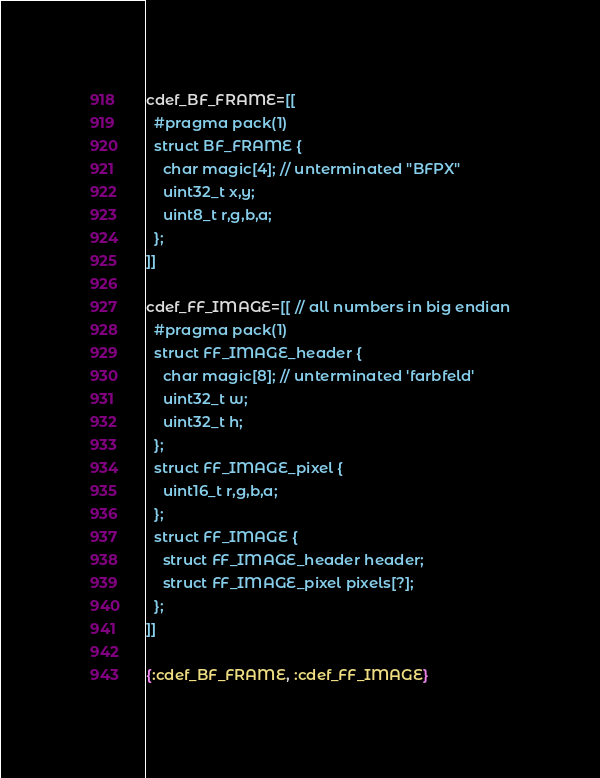<code> <loc_0><loc_0><loc_500><loc_500><_MoonScript_>cdef_BF_FRAME=[[
  #pragma pack(1)
  struct BF_FRAME {
    char magic[4]; // unterminated "BFPX"
    uint32_t x,y;
    uint8_t r,g,b,a;
  };
]]

cdef_FF_IMAGE=[[ // all numbers in big endian
  #pragma pack(1)
  struct FF_IMAGE_header {
    char magic[8]; // unterminated 'farbfeld'
    uint32_t w;
    uint32_t h;
  };
  struct FF_IMAGE_pixel {
    uint16_t r,g,b,a;
  };
  struct FF_IMAGE {
    struct FF_IMAGE_header header;
    struct FF_IMAGE_pixel pixels[?];
  };
]]

{:cdef_BF_FRAME, :cdef_FF_IMAGE}
</code> 